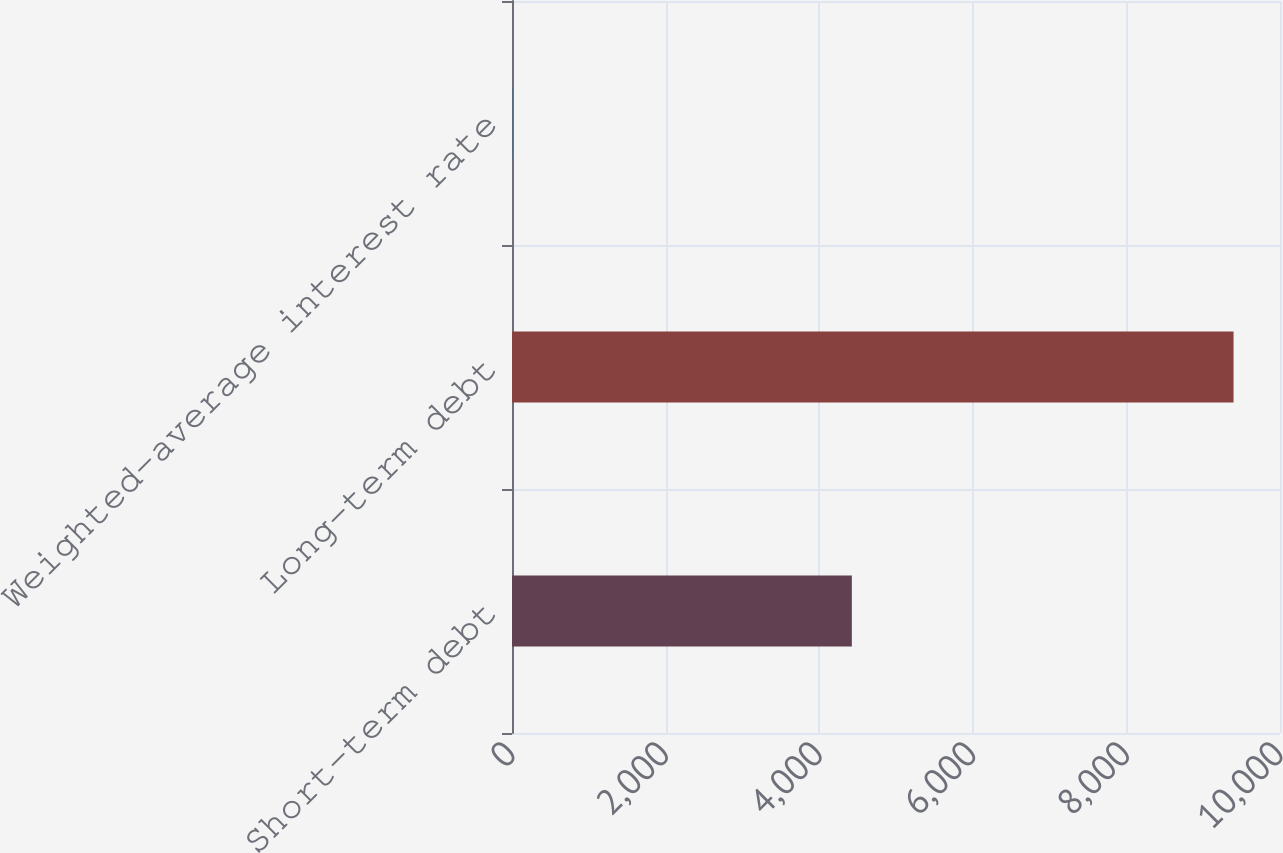Convert chart to OTSL. <chart><loc_0><loc_0><loc_500><loc_500><bar_chart><fcel>Short-term debt<fcel>Long-term debt<fcel>Weighted-average interest rate<nl><fcel>4425<fcel>9395<fcel>4.1<nl></chart> 